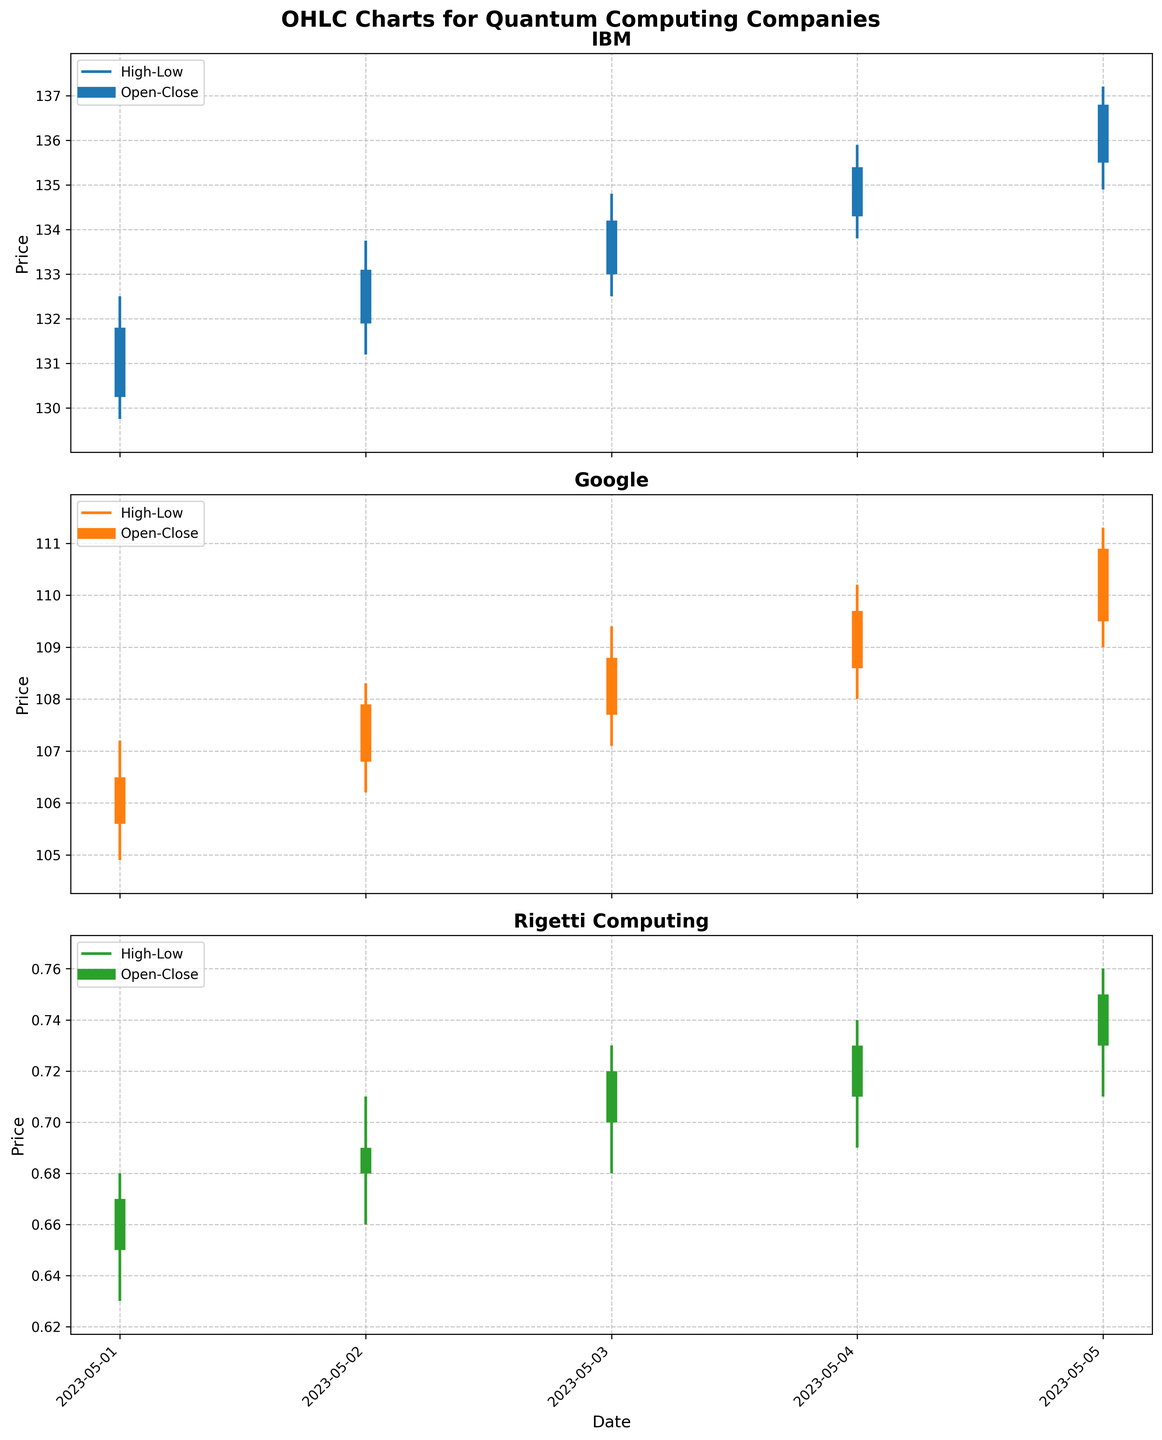what are the colors used for the lines representing high-low and open-close price movements? The lines representing high-low and open-close price movements are colored in different shades. The high-low lines are colored with a medium shade, while the open-close lines are thicker and use the same color but in a bolder appearance.
Answer: Medium and bold shades of blue, orange, and green Which company's stock shows the highest closing price on May 5, 2023? To find the highest closing price among the companies on May 5, 2023, look at the closing price values. For IBM, it's 136.80; for Google, it's 110.90; and for Rigetti Computing, it's 0.75. IBM has the highest closing price.
Answer: IBM What is the range (high minus low) of Google's stock prices on May 3, 2023? The range is calculated by subtracting the lowest price from the highest price on May 3 for Google. The high is 109.40 and the low is 107.10, so the range is 109.40 - 107.10.
Answer: 2.30 Which company had the smallest difference between high and low prices on May 1, 2023? To find the smallest difference between high and low prices on May 1, compare the differences for each company. IBM: 132.50 - 129.75 = 2.75, Google: 107.20 - 104.90 = 2.30, Rigetti Computing: 0.68 - 0.63 = 0.05. Rigetti Computing has the smallest difference.
Answer: Rigetti Computing On what date did IBM first close above 134? To determine this, look at the closing prices for IBM over the dates. IBM first closed at 134.20 on May 3, 2023.
Answer: May 3, 2023 How many days did Rigetti Computing's stock close higher than it opened? Compare the opening and closing prices for each day for Rigetti Computing. The stock closed higher than it opened on May 2 (0.69 > 0.68), May 3 (0.72 > 0.70), May 4 (0.73 > 0.71), and May 5 (0.75 > 0.73). This happened on 4 days.
Answer: 4 days Which company showed the largest percentage increase in closing price from May 1 to May 5? Calculate the percentage increase using the formula: \( \frac{{\text{Close on May 5} - \text{Close on May 1}}}{\text{Close on May 1}} \times 100 \). IBM: \( \frac{136.80 - 131.80}{131.80} \times 100 = 3.79\% \), Google: \( \frac{110.90 - 106.50}{106.50} \times 100 = 4.14\% \), Rigetti Computing: \( \frac{0.75 - 0.67}{0.67} \times 100 = 11.94\% \). Rigetti Computing has the largest percentage increase.
Answer: Rigetti Computing Between May 2 and May 4, did Google or IBM experience more consistent daily closing price increases? Check if the closing prices for each day increase continuously from May 2 to May 4. IBM: May 2: 133.10; May 3: 134.20; May 4: 135.40 (consistent increase). Google: May 2: 107.90; May 3: 108.80; May 4: 109.70 (consistent increase). Both experienced consistent increases, but IBM had higher absolute values each day.
Answer: Both Google and IBM Did the high prices of Rigetti Computing ever exceed 0.72 within the observed period? Check the high prices for Rigetti Computing from May 1 to May 5. The high prices are 0.68, 0.71, 0.73, 0.74, and 0.76, respectively. On May 3, May 4, and May 5, the high prices exceeded 0.72.
Answer: Yes 